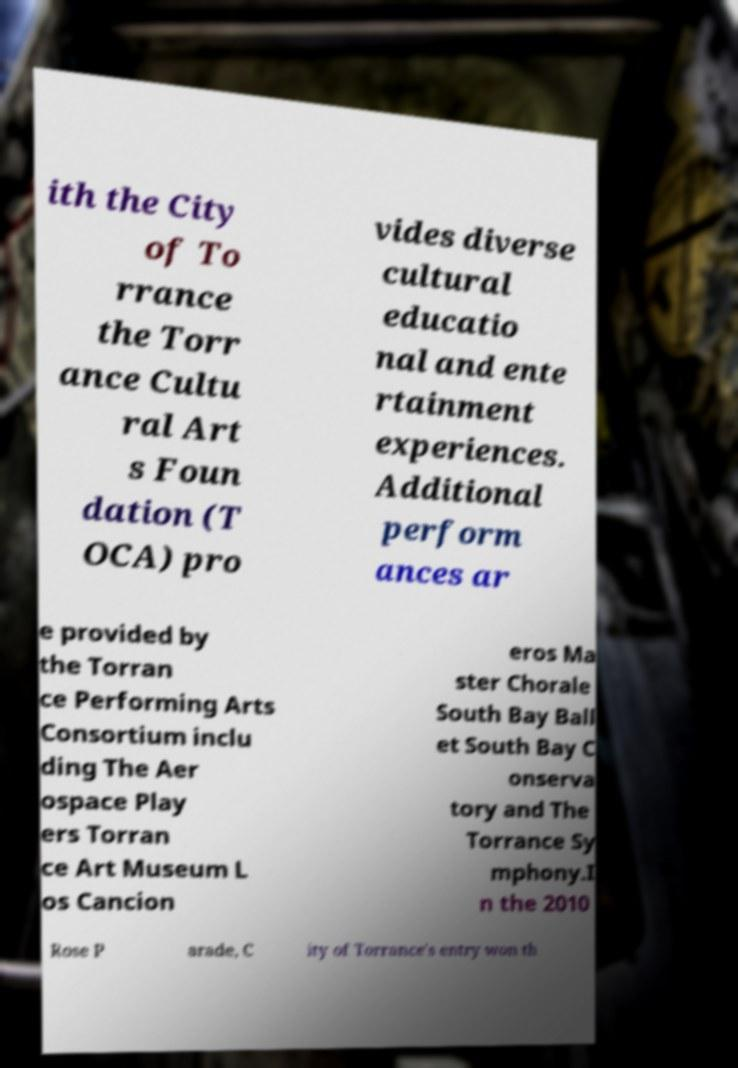I need the written content from this picture converted into text. Can you do that? ith the City of To rrance the Torr ance Cultu ral Art s Foun dation (T OCA) pro vides diverse cultural educatio nal and ente rtainment experiences. Additional perform ances ar e provided by the Torran ce Performing Arts Consortium inclu ding The Aer ospace Play ers Torran ce Art Museum L os Cancion eros Ma ster Chorale South Bay Ball et South Bay C onserva tory and The Torrance Sy mphony.I n the 2010 Rose P arade, C ity of Torrance's entry won th 